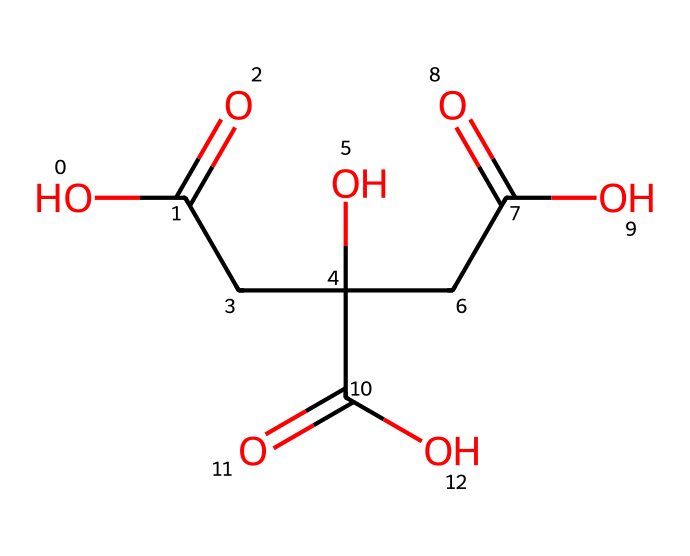What is the chemical name of this compound? The provided SMILES representation corresponds to a well-known organic acid, commonly found in citrus fruits and used as a cleaning agent. The name can be derived from its structural formula, which contains multiple carboxylic acid groups.
Answer: citric acid How many carboxylic acid groups are in citric acid? The structure of citric acid can be analyzed to identify the presence of functional groups. There are three distinct –COOH groups visible, confirming the total count.
Answer: 3 What is the total number of carbon atoms in citric acid? By examining the skeletal structure derived from the SMILES notation, we count the carbon atoms present in the main structure, which gives a total of six carbon positions.
Answer: 6 Which part of the citric acid molecule contributes to its acidic properties? The acidic nature comes from the carboxylic acid functional groups (–COOH), which are responsible for donating protons (H+) in solution. Identifying these functional groups confirms their contribution to acidity.
Answer: carboxylic acid groups How does the presence of multiple hydroxyl groups affect citric acid's solubility? The hydroxyl (–OH) groups enhance the molecule's polarity and ability to form hydrogen bonds with water, significantly increasing its solubility in aqueous solutions compared to less polar compounds. This solubility factor is critical for its use in cleaning applications.
Answer: increases solubility What type of cleaning benefits does citric acid have for electric vehicle charging ports? Citric acid is a natural chelating agent that can effectively break down mineral deposits and remove oxide build-up without damaging the underlying surfaces. This property arises from its acidic nature and complex formation ability.
Answer: removes mineral deposits How does the structural arrangement impact the reactivity of citric acid in cleaning solutions? The specific arrangement of the carboxylic acid and hydroxyl groups allows for effective interactions with various contaminants, making citric acid a versatile cleaning agent. The proximity of these functional groups also enhances reactivity with other substances present in cleaning applications.
Answer: enhances reactivity 